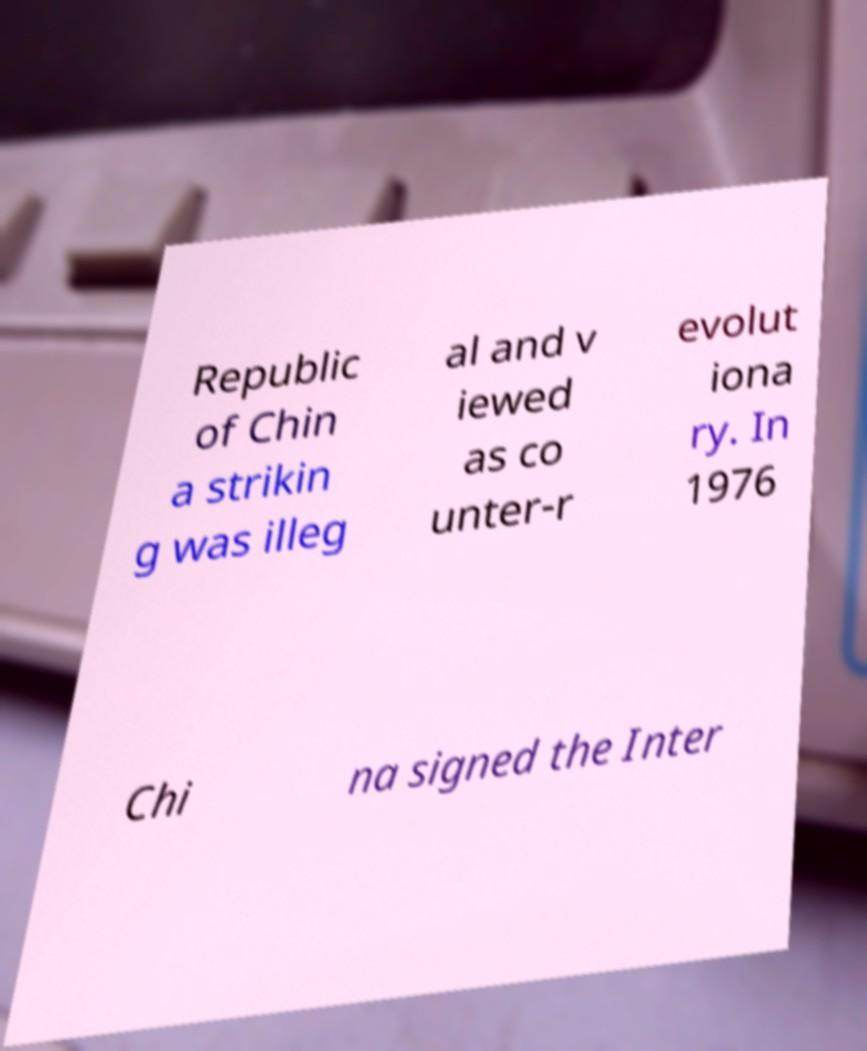Can you accurately transcribe the text from the provided image for me? Republic of Chin a strikin g was illeg al and v iewed as co unter-r evolut iona ry. In 1976 Chi na signed the Inter 